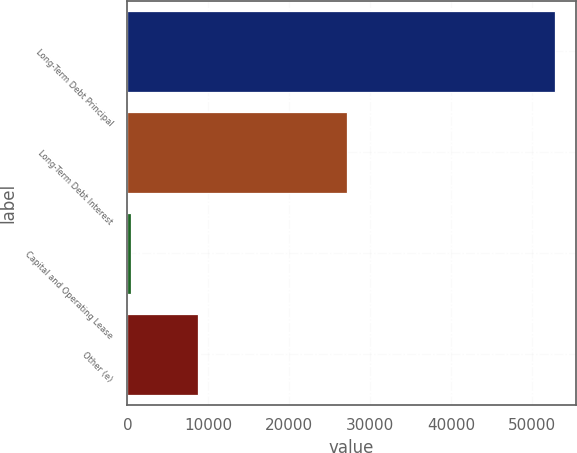<chart> <loc_0><loc_0><loc_500><loc_500><bar_chart><fcel>Long-Term Debt Principal<fcel>Long-Term Debt Interest<fcel>Capital and Operating Lease<fcel>Other (e)<nl><fcel>52768<fcel>27086<fcel>495<fcel>8687<nl></chart> 